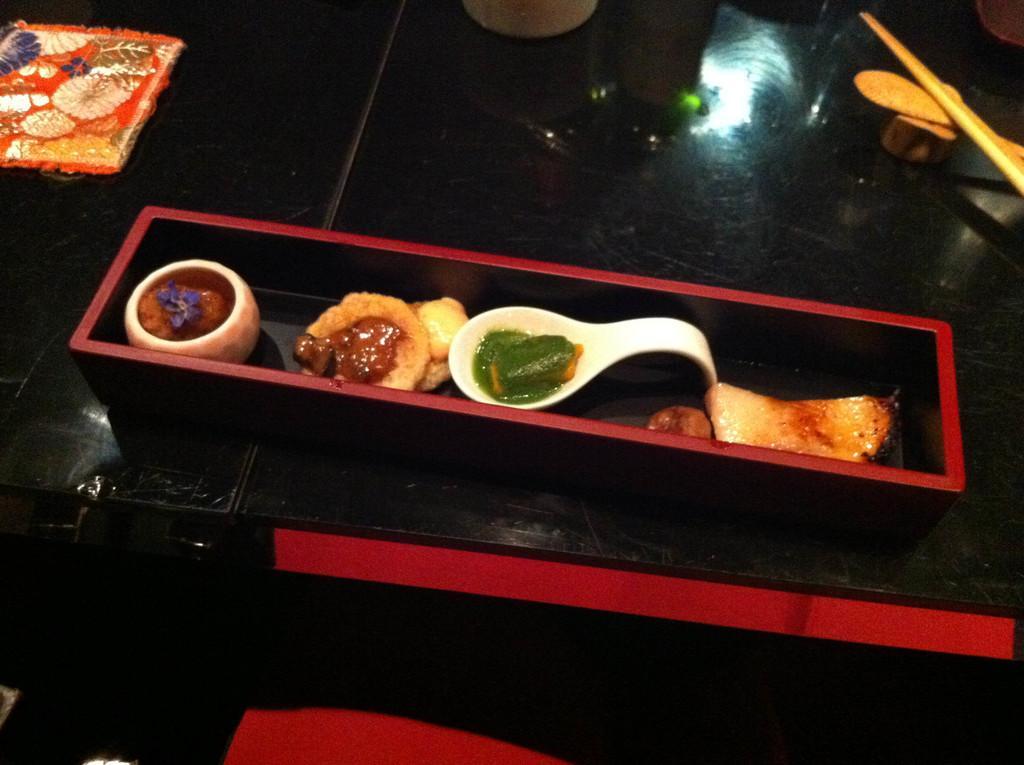In one or two sentences, can you explain what this image depicts? There is a table with a red border on that. On the table there is a box. Inside that there are some food items, bowl with a food item and another plate with a food item. On the left side there is something. On the right side there is a spoon and chopstick. 